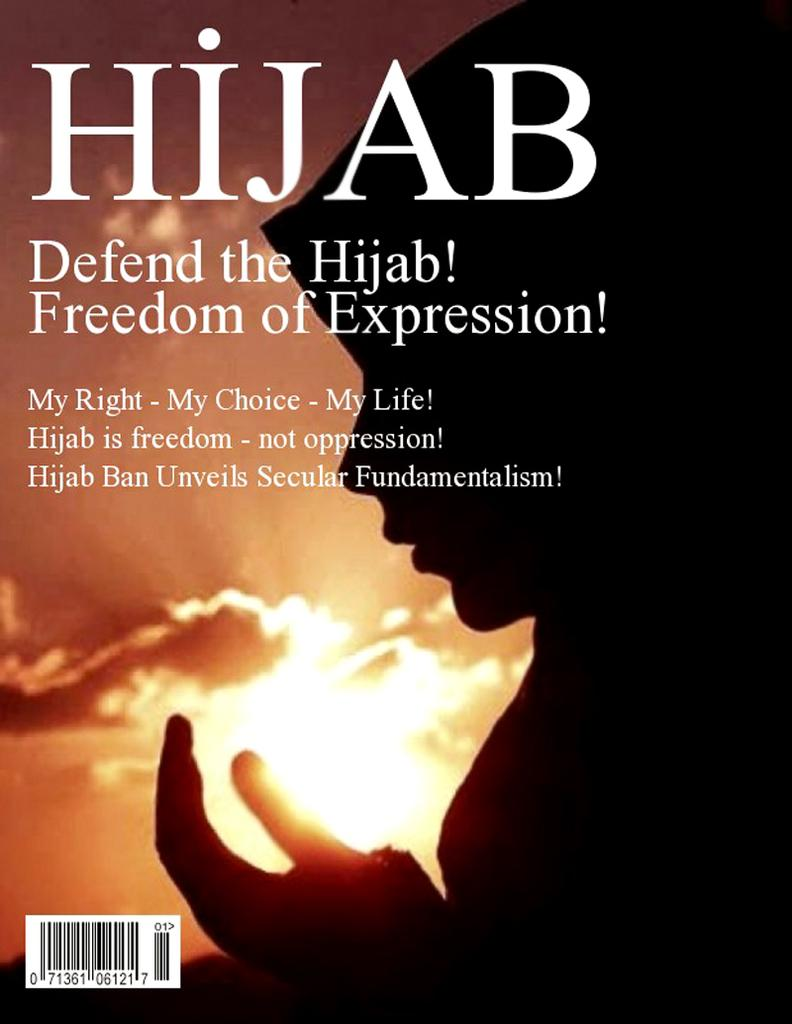What is the main subject of the image? There is a dark shade of a woman in the image. Are there any textual elements in the image? Yes, there is edited text in the image. What can be seen in the sky in the image? The sun is visible in the sky, and there are clouds present. What type of code is visible in the image? There is a barcode in the image. What year is depicted in the image? There is no specific year depicted in the image. What emotion is being expressed by the woman in the image? The image does not convey any specific emotion, as it is a dark shade of a woman. What type of chalk is being used to draw on the woman's face in the image? There is no chalk or drawing on the woman's face in the image. 